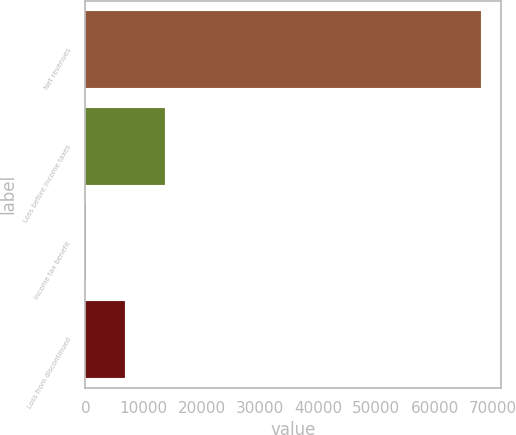Convert chart to OTSL. <chart><loc_0><loc_0><loc_500><loc_500><bar_chart><fcel>Net revenues<fcel>Loss before income taxes<fcel>Income tax benefit<fcel>Loss from discontinued<nl><fcel>67990<fcel>13663.6<fcel>82<fcel>6872.8<nl></chart> 